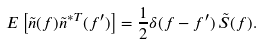Convert formula to latex. <formula><loc_0><loc_0><loc_500><loc_500>E \left [ \tilde { n } ( f ) \tilde { n } ^ { * T } ( f ^ { \prime } ) \right ] = \frac { 1 } { 2 } \delta ( f - f ^ { \prime } ) \, \tilde { S } ( f ) .</formula> 